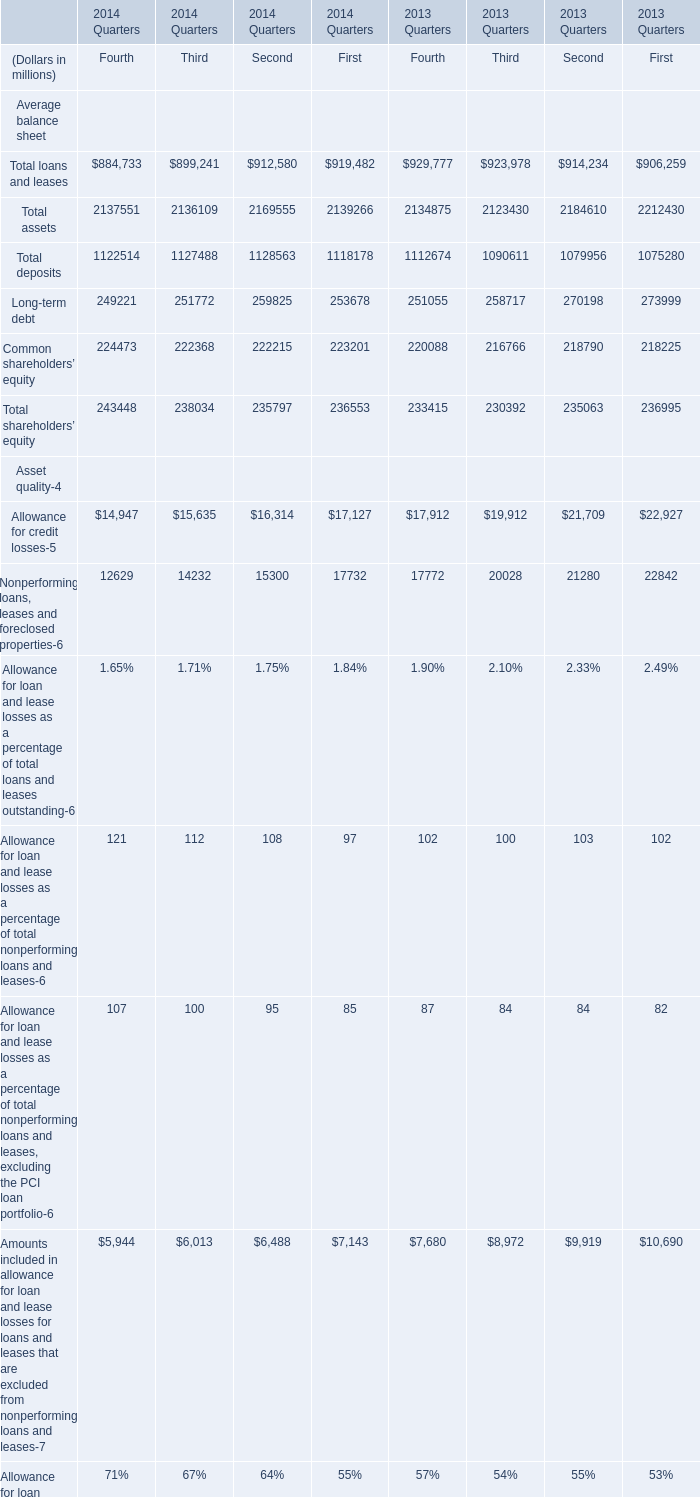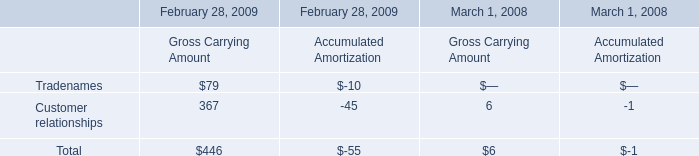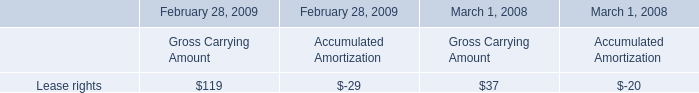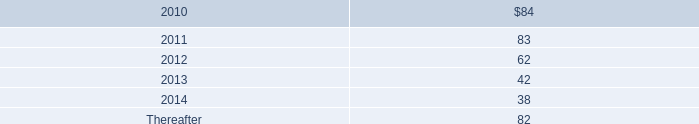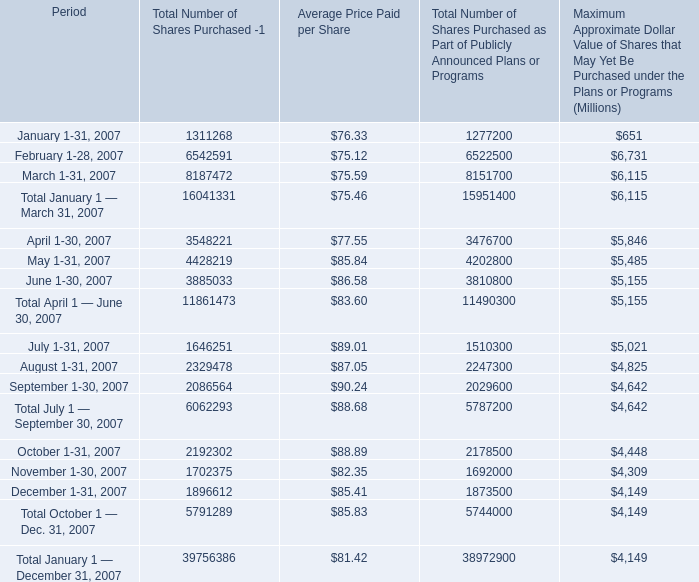what was the percent of the total tumber of shares purchased that was not of the shares purchased as part of publicly announced plans or programs 
Computations: ((39756386 - 38972900) / 38972900)
Answer: 0.0201. 